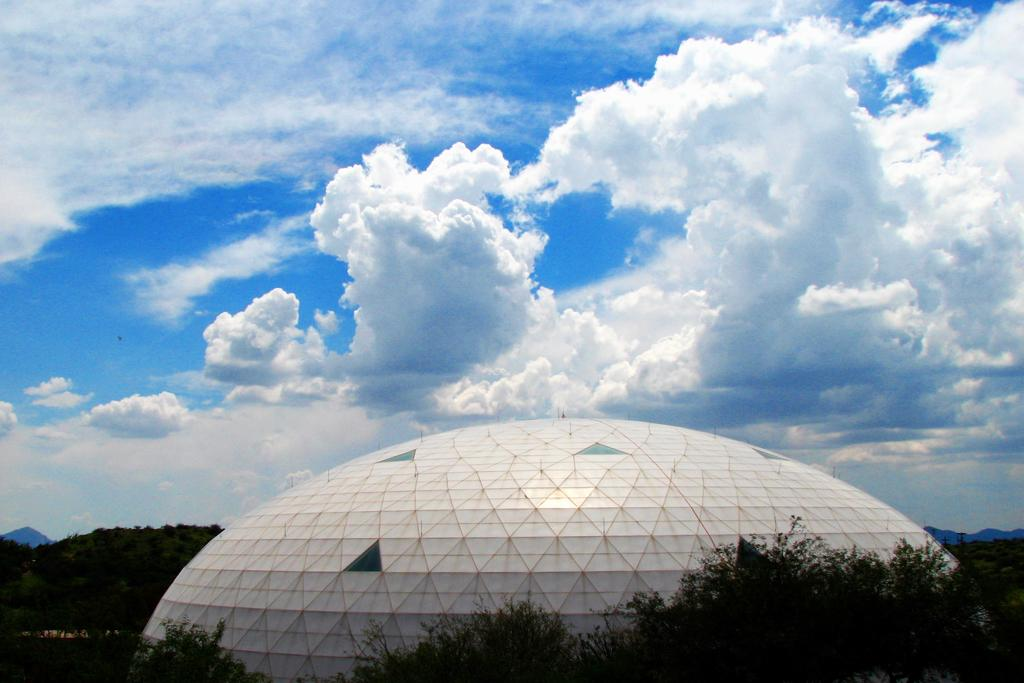What type of vegetation can be seen in the image? There are trees in the image. What structure is located in the front of the image? There is a building in the front of the image. What can be seen in the background of the image? There are clouds and the sky visible in the background of the image. What type of ink is being used to write on the trees in the image? There is no ink or writing present on the trees in the image. Is the wilderness visible in the image? The image does not depict a wilderness setting; it features trees, a building, clouds, and the sky. 